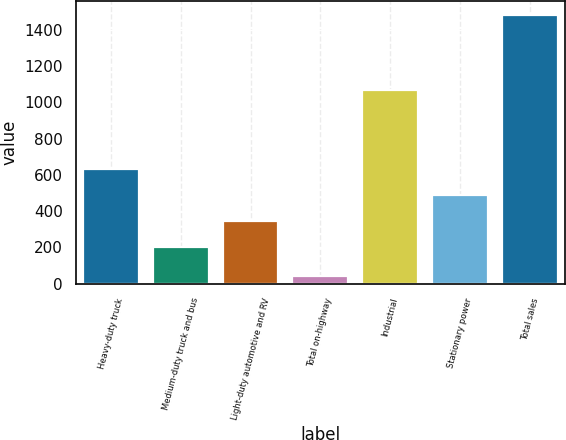Convert chart. <chart><loc_0><loc_0><loc_500><loc_500><bar_chart><fcel>Heavy-duty truck<fcel>Medium-duty truck and bus<fcel>Light-duty automotive and RV<fcel>Total on-highway<fcel>Industrial<fcel>Stationary power<fcel>Total sales<nl><fcel>634.7<fcel>203<fcel>346.9<fcel>44<fcel>1068<fcel>490.8<fcel>1483<nl></chart> 